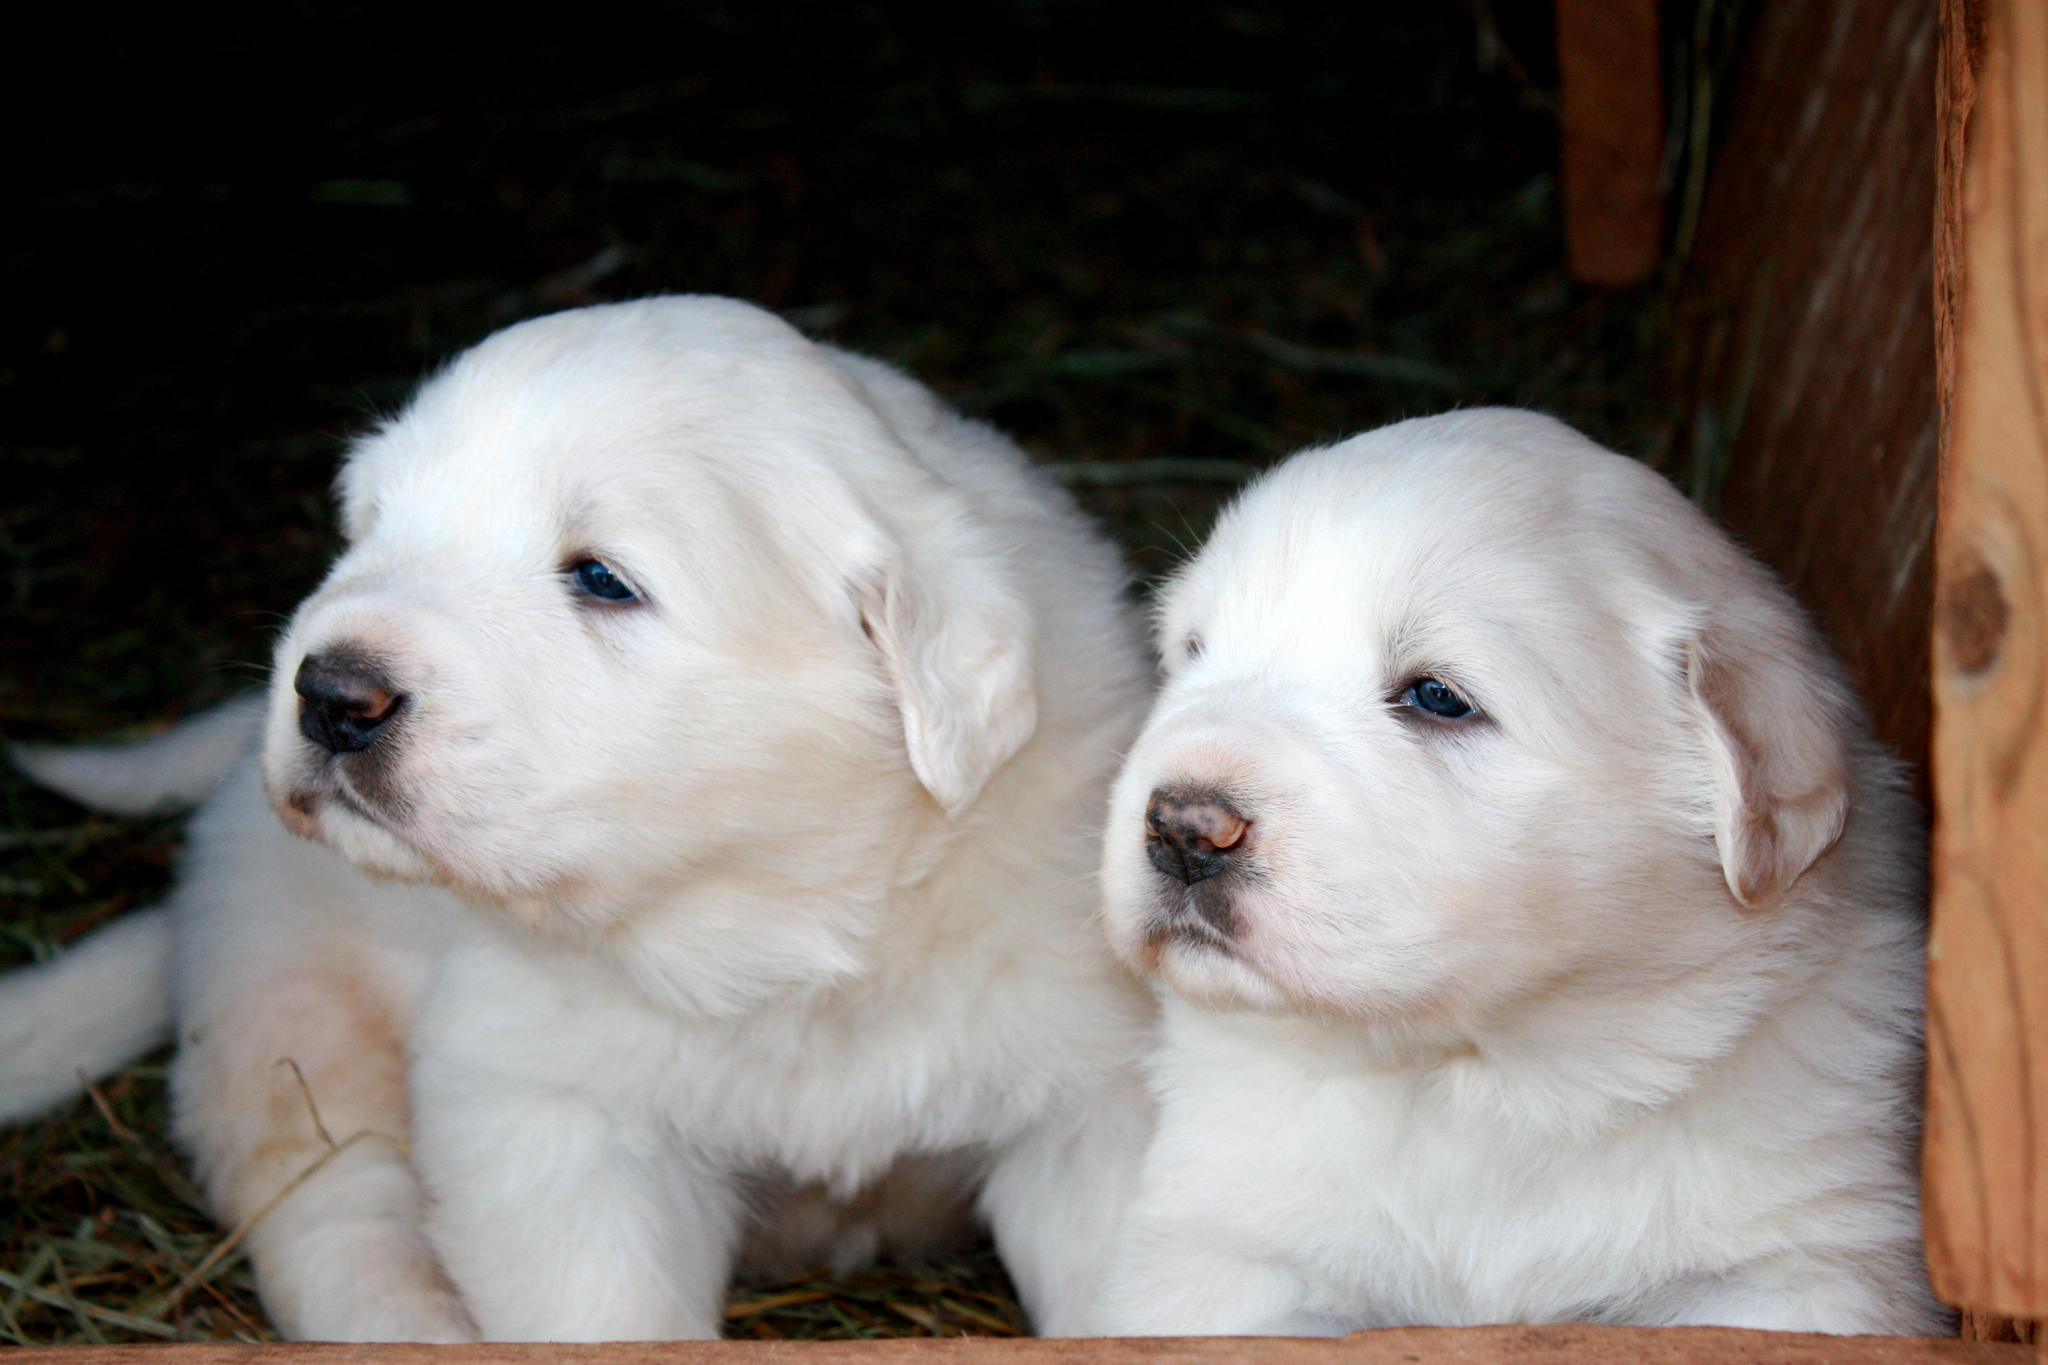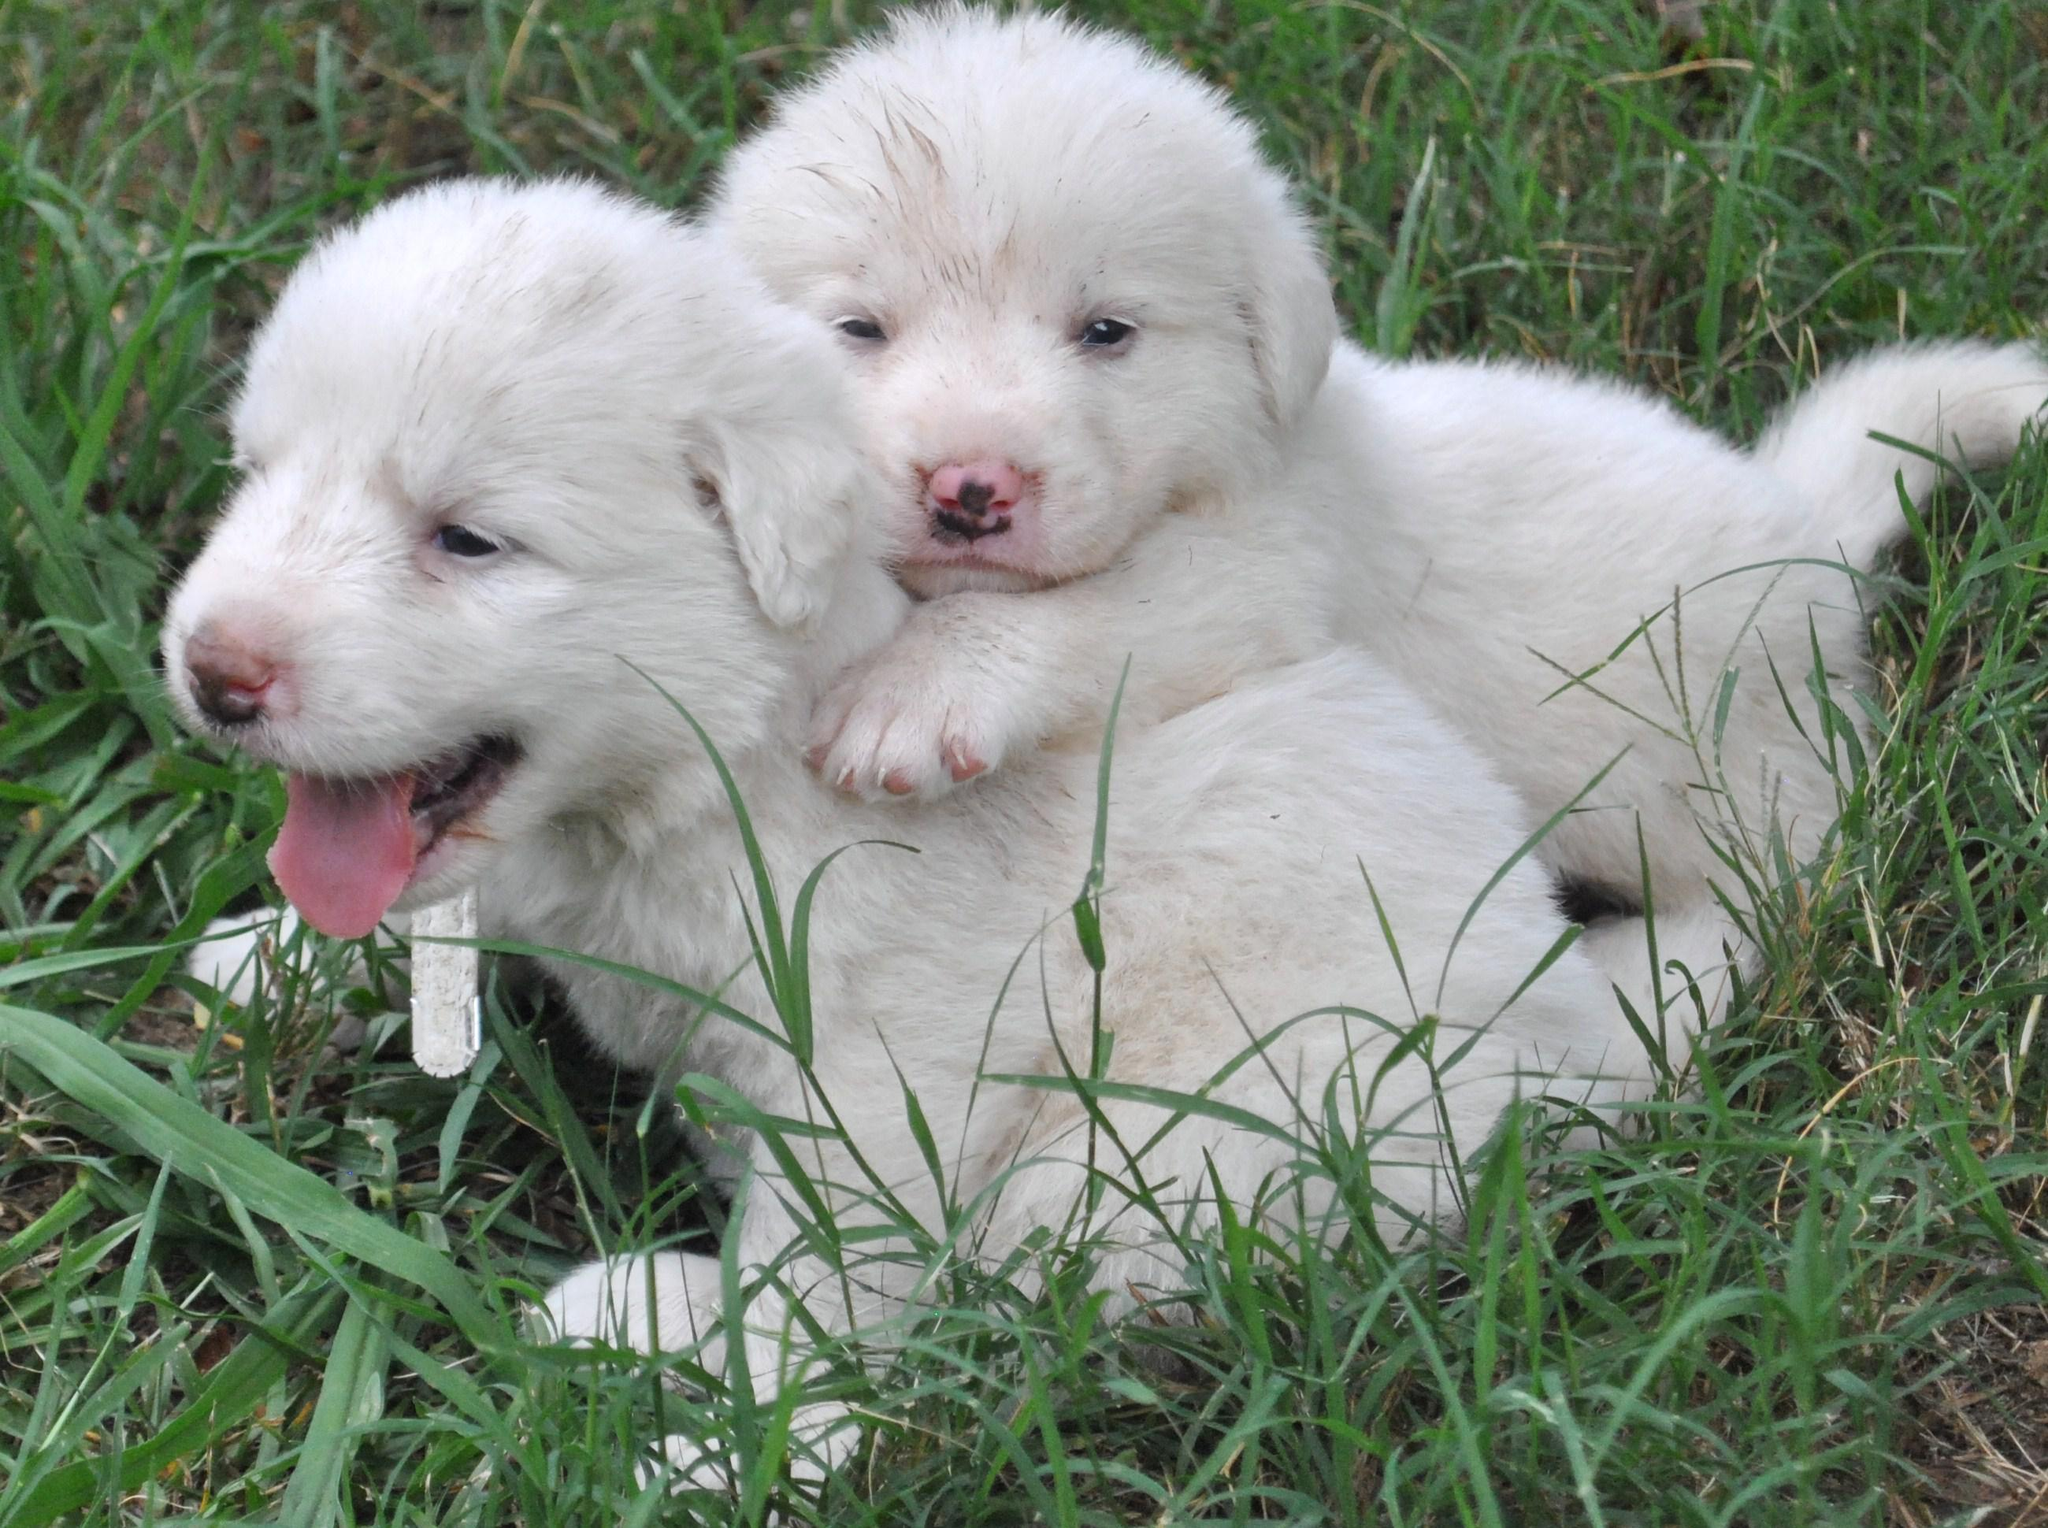The first image is the image on the left, the second image is the image on the right. Analyze the images presented: Is the assertion "There are two dogs together in front of a visible sky in each image." valid? Answer yes or no. No. 